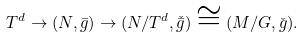Convert formula to latex. <formula><loc_0><loc_0><loc_500><loc_500>T ^ { d } \rightarrow ( N , \bar { g } ) \rightarrow ( N / T ^ { d } , \check { \bar { g } } ) \cong ( M / G , \check { g } ) .</formula> 